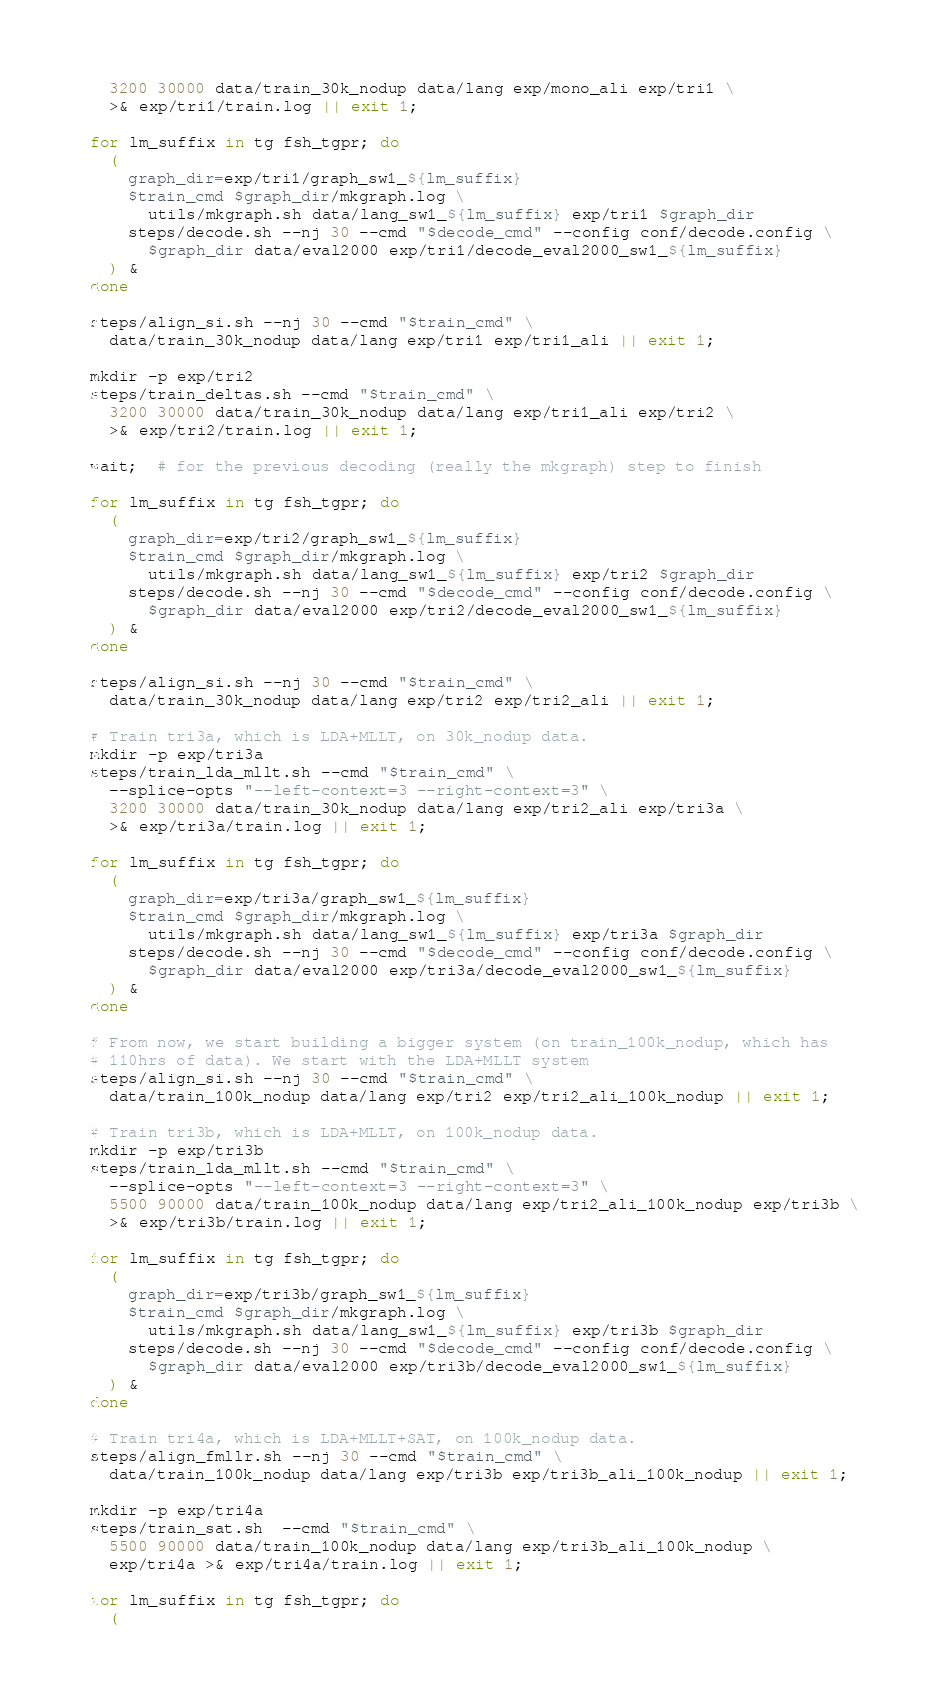Convert code to text. <code><loc_0><loc_0><loc_500><loc_500><_Bash_>  3200 30000 data/train_30k_nodup data/lang exp/mono_ali exp/tri1 \
  >& exp/tri1/train.log || exit 1;

for lm_suffix in tg fsh_tgpr; do
  (
    graph_dir=exp/tri1/graph_sw1_${lm_suffix}
    $train_cmd $graph_dir/mkgraph.log \
      utils/mkgraph.sh data/lang_sw1_${lm_suffix} exp/tri1 $graph_dir
    steps/decode.sh --nj 30 --cmd "$decode_cmd" --config conf/decode.config \
      $graph_dir data/eval2000 exp/tri1/decode_eval2000_sw1_${lm_suffix}
  ) &
done

steps/align_si.sh --nj 30 --cmd "$train_cmd" \
  data/train_30k_nodup data/lang exp/tri1 exp/tri1_ali || exit 1;

mkdir -p exp/tri2
steps/train_deltas.sh --cmd "$train_cmd" \
  3200 30000 data/train_30k_nodup data/lang exp/tri1_ali exp/tri2 \
  >& exp/tri2/train.log || exit 1;

wait;  # for the previous decoding (really the mkgraph) step to finish

for lm_suffix in tg fsh_tgpr; do
  (
    graph_dir=exp/tri2/graph_sw1_${lm_suffix}
    $train_cmd $graph_dir/mkgraph.log \
      utils/mkgraph.sh data/lang_sw1_${lm_suffix} exp/tri2 $graph_dir
    steps/decode.sh --nj 30 --cmd "$decode_cmd" --config conf/decode.config \
      $graph_dir data/eval2000 exp/tri2/decode_eval2000_sw1_${lm_suffix}
  ) &
done

steps/align_si.sh --nj 30 --cmd "$train_cmd" \
  data/train_30k_nodup data/lang exp/tri2 exp/tri2_ali || exit 1;

# Train tri3a, which is LDA+MLLT, on 30k_nodup data.
mkdir -p exp/tri3a
steps/train_lda_mllt.sh --cmd "$train_cmd" \
  --splice-opts "--left-context=3 --right-context=3" \
  3200 30000 data/train_30k_nodup data/lang exp/tri2_ali exp/tri3a \
  >& exp/tri3a/train.log || exit 1;

for lm_suffix in tg fsh_tgpr; do
  (
    graph_dir=exp/tri3a/graph_sw1_${lm_suffix}
    $train_cmd $graph_dir/mkgraph.log \
      utils/mkgraph.sh data/lang_sw1_${lm_suffix} exp/tri3a $graph_dir
    steps/decode.sh --nj 30 --cmd "$decode_cmd" --config conf/decode.config \
      $graph_dir data/eval2000 exp/tri3a/decode_eval2000_sw1_${lm_suffix}
  ) &
done

# From now, we start building a bigger system (on train_100k_nodup, which has 
# 110hrs of data). We start with the LDA+MLLT system
steps/align_si.sh --nj 30 --cmd "$train_cmd" \
  data/train_100k_nodup data/lang exp/tri2 exp/tri2_ali_100k_nodup || exit 1;

# Train tri3b, which is LDA+MLLT, on 100k_nodup data.
mkdir -p exp/tri3b
steps/train_lda_mllt.sh --cmd "$train_cmd" \
  --splice-opts "--left-context=3 --right-context=3" \
  5500 90000 data/train_100k_nodup data/lang exp/tri2_ali_100k_nodup exp/tri3b \
  >& exp/tri3b/train.log || exit 1;

for lm_suffix in tg fsh_tgpr; do
  (
    graph_dir=exp/tri3b/graph_sw1_${lm_suffix}
    $train_cmd $graph_dir/mkgraph.log \
      utils/mkgraph.sh data/lang_sw1_${lm_suffix} exp/tri3b $graph_dir
    steps/decode.sh --nj 30 --cmd "$decode_cmd" --config conf/decode.config \
      $graph_dir data/eval2000 exp/tri3b/decode_eval2000_sw1_${lm_suffix}
  ) &
done

# Train tri4a, which is LDA+MLLT+SAT, on 100k_nodup data.
steps/align_fmllr.sh --nj 30 --cmd "$train_cmd" \
  data/train_100k_nodup data/lang exp/tri3b exp/tri3b_ali_100k_nodup || exit 1;

mkdir -p exp/tri4a
steps/train_sat.sh  --cmd "$train_cmd" \
  5500 90000 data/train_100k_nodup data/lang exp/tri3b_ali_100k_nodup \
  exp/tri4a >& exp/tri4a/train.log || exit 1;

for lm_suffix in tg fsh_tgpr; do
  (</code> 